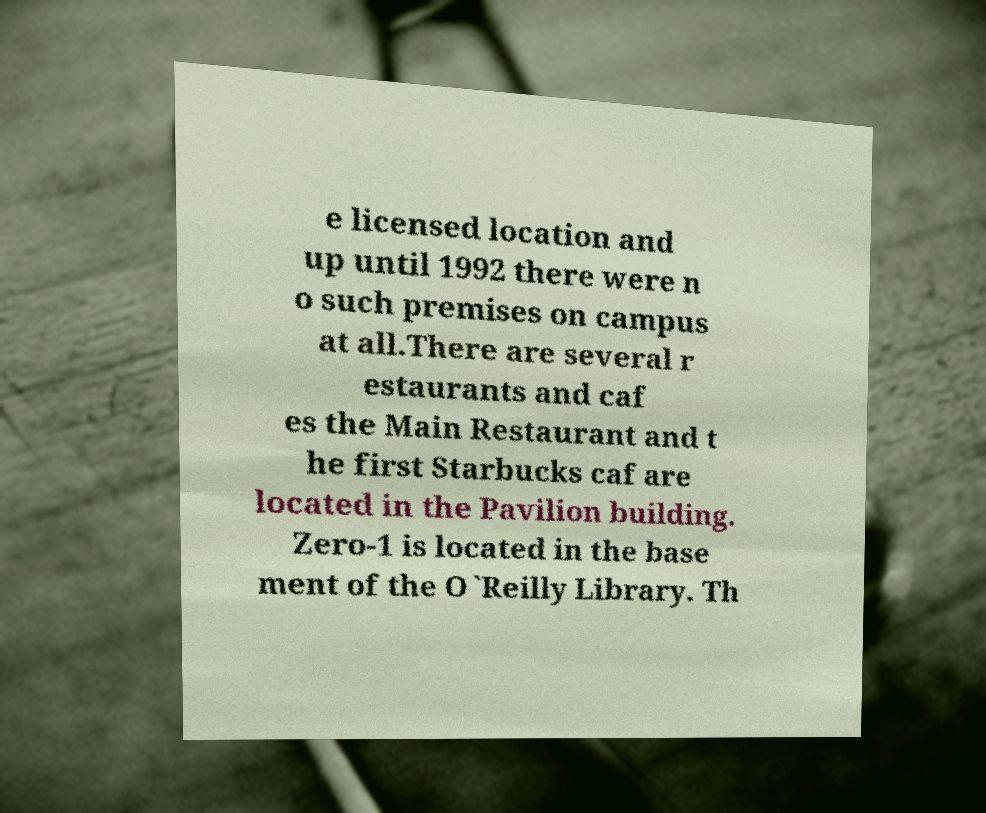Please read and relay the text visible in this image. What does it say? e licensed location and up until 1992 there were n o such premises on campus at all.There are several r estaurants and caf es the Main Restaurant and t he first Starbucks caf are located in the Pavilion building. Zero-1 is located in the base ment of the O`Reilly Library. Th 